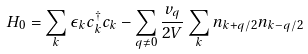Convert formula to latex. <formula><loc_0><loc_0><loc_500><loc_500>H _ { 0 } = \sum _ { k } \epsilon _ { k } c ^ { \dagger } _ { k } c _ { k } - \sum _ { { q } \neq 0 } \frac { v _ { q } } { 2 V } \sum _ { k } n _ { { k } + { q } / 2 } n _ { { k } - { q } / 2 }</formula> 